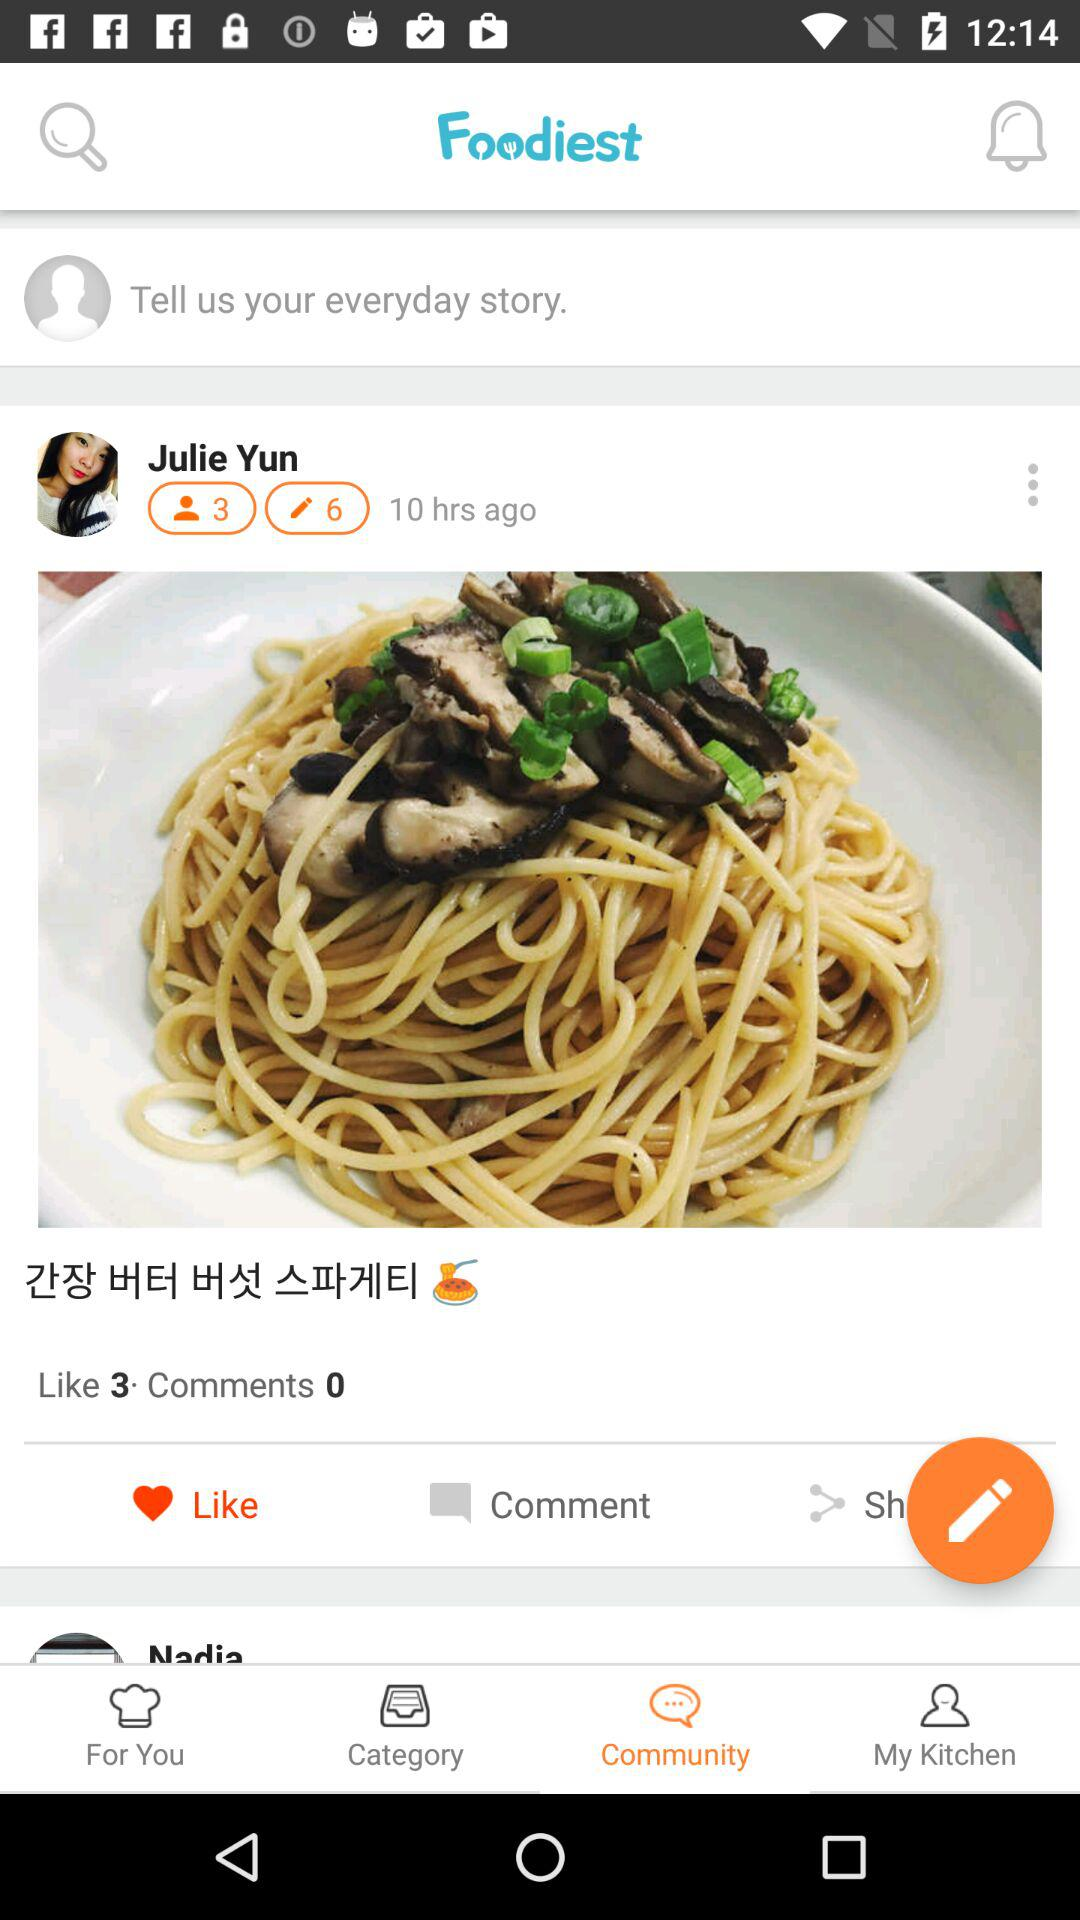How many more people liked the recipe than commented on it?
Answer the question using a single word or phrase. 3 